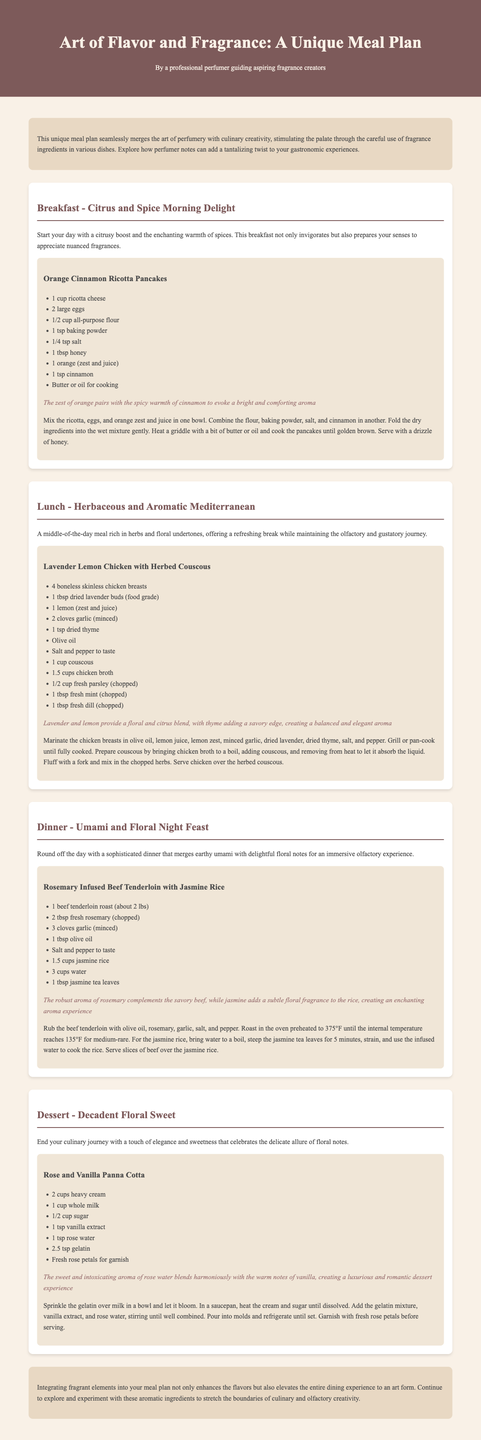What is the title of the meal plan? The title of the meal plan is located in the header section of the document.
Answer: Art of Flavor and Fragrance: A Unique Meal Plan How many meals are included in the plan? The document lists a total of four meals: Breakfast, Lunch, Dinner, and Dessert.
Answer: 4 What is the main ingredient in the breakfast recipe? The breakfast recipe emphasizes ricotta cheese as a significant component.
Answer: Ricotta cheese Which herb is used in the lunch recipe? The lunch recipe highlights the use of dried lavender buds.
Answer: Lavender What is the fragrance highlight of the dinner recipe? The dinner recipe features a blend of rosemary and jasmine as its spiritual aromas.
Answer: Rosemary and jasmine What type of dessert is featured in the meal plan? The dessert section specifies a panna cotta as its primary feature.
Answer: Panna Cotta What cooking method is mentioned for the chicken in the lunch meal? The document describes grilling or pan-cooking as the method for preparing the chicken.
Answer: Grilling or pan-cooking How is the charm of the floral notes expressed in the dessert? The dessert emphasizes the blend of rose water and vanilla, highlighting floral qualities.
Answer: Rose and vanilla What is the total number of ingredients listed for the dinner recipe? The dinner recipe lists seven distinct ingredients required for preparation.
Answer: 7 What sensory experience does the meal plan aim to enhance? The document expresses a focus on stimulating the palate through fragrant ingredients.
Answer: Palate stimulation 